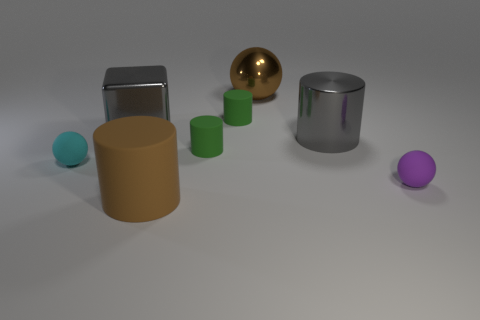Subtract all blue cylinders. Subtract all brown spheres. How many cylinders are left? 4 Add 1 big gray blocks. How many objects exist? 9 Subtract all blocks. How many objects are left? 7 Add 2 gray things. How many gray things exist? 4 Subtract 1 cyan spheres. How many objects are left? 7 Subtract all gray cubes. Subtract all metal blocks. How many objects are left? 6 Add 3 matte objects. How many matte objects are left? 8 